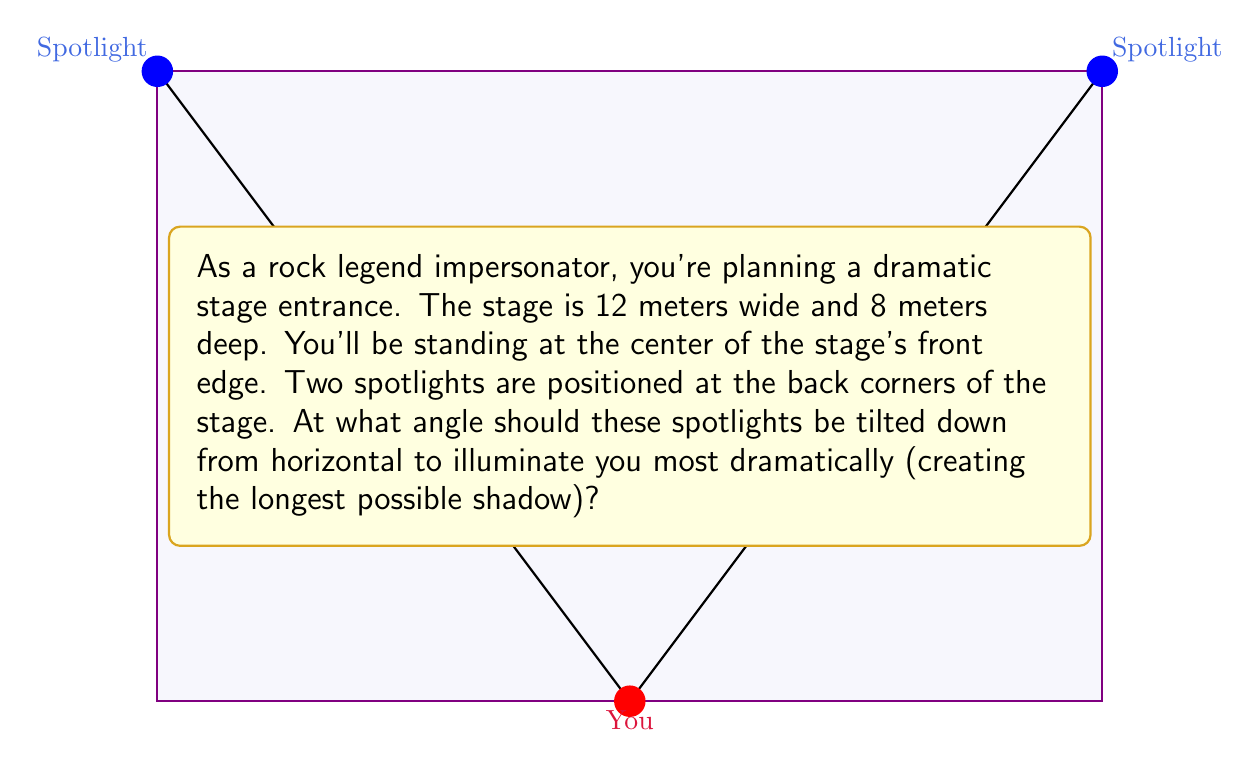What is the answer to this math problem? Let's approach this step-by-step:

1) First, we need to understand that the longest shadow will be created when the light rays are at the smallest angle to the stage floor.

2) We can treat this as a right-angled triangle problem. The spotlight forms the hypotenuse of this triangle.

3) The base of the triangle is half the stage width (since you're at the center of the front edge). So the base is 6 meters.

4) The height of the triangle is the stage depth, 8 meters.

5) We can use the arctangent function to find the angle. Let's call this angle θ.

6) $$ \tan(\theta) = \frac{\text{opposite}}{\text{adjacent}} = \frac{8}{6} = \frac{4}{3} $$

7) Therefore, $$ \theta = \arctan(\frac{4}{3}) $$

8) Using a calculator or computer, we can determine that:
   $$ \theta \approx 53.13^\circ $$

9) This is the angle from horizontal. To get the angle down from horizontal, we subtract from 90°:
   $$ 90^\circ - 53.13^\circ = 36.87^\circ $$

10) Round to the nearest degree for practical application.
Answer: 37° 